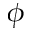Convert formula to latex. <formula><loc_0><loc_0><loc_500><loc_500>\phi</formula> 